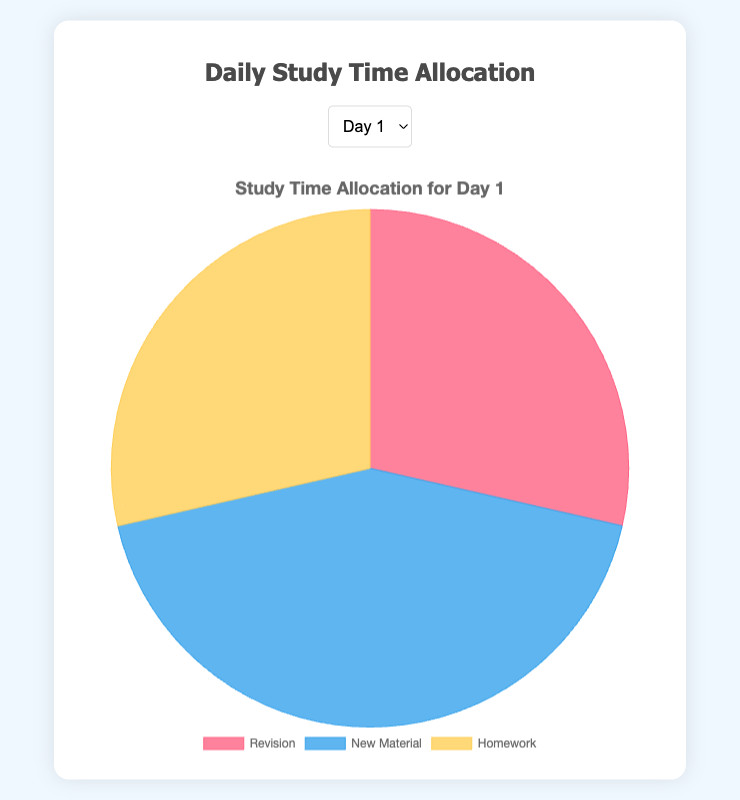Which day had the most time spent on New Material? By referring to the pie chart for each day, Day 5 had the largest portion dedicated to New Material compared to other categories.
Answer: Day 5 What is the sum of Revision and Homework time on Day 3? On Day 3, the time spent on Revision is 2 hours, and Homework is also 2 hours. Adding these together, 2 + 2 = 4 hours.
Answer: 4 hours Which day had the least time spent on Revision? Observing the pie charts for all days, Day 4 and Day 7 had the smallest portions for Revision. Both days show 1 hour spent on Revision.
Answer: Day 4 and Day 7 Is the time spent on Homework on Day 1 greater than or equal to the time spent on Revision on Day 1? Day 1's pie chart shows both Homework and Revision each with 2 hours, meaning they are equal.
Answer: Yes, they are equal What is the average time spent on New Material over the 7 days? Summing the New Material times: 3 + 2 + 2.5 + 3.5 + 4 + 2.5 + 3 = 20.5 hours. Dividing by 7, the average is 20.5 / 7 ≈ 2.93 hours.
Answer: Approximately 2.93 hours Which category had the smallest portion on Day 2? On Day 2, the smallest portion of the pie chart corresponds to Revision and Homework, with each having 1.5 hours.
Answer: Revision and Homework Is the time spent on Homework on Day 5 less than the time spent on New Material on the same day? On Day 5, the time spent on Homework is 2.5 hours, whereas the time spent on New Material is 4 hours. 2.5 < 4, so yes.
Answer: Yes Which day had an equal amount of time spent on Revision and Homework? The pie charts for Day 1, Day 3, and Day 7 show equal portions for Revision and Homework, with each day having them equally allocated in terms of hours.
Answer: Day 1, Day 3, and Day 7 What is the total study time on Day 2? Day 2's pie chart shows Revision: 1.5 hours, New Material: 2 hours, Homework: 1.5 hours. Summing these, 1.5 + 2 + 1.5 = 5 hours.
Answer: 5 hours 